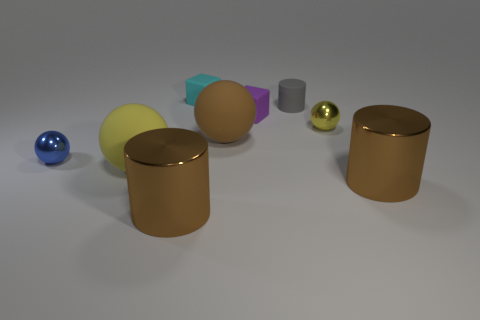There is a yellow metal thing that is the same shape as the blue thing; what size is it? The yellow metal object appears to be a medium-sized cylinder, comparable in size to the larger blue sphere nearby but noticeably smaller than the two larger cylinders seen on the far right. 